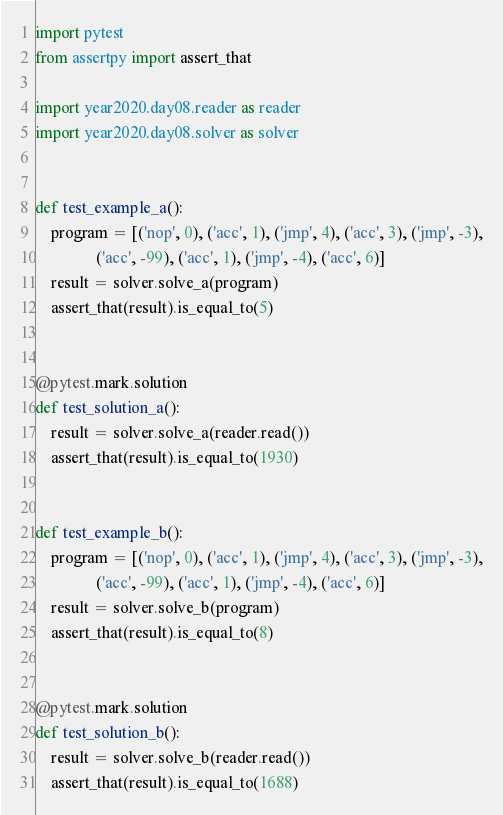Convert code to text. <code><loc_0><loc_0><loc_500><loc_500><_Python_>import pytest
from assertpy import assert_that

import year2020.day08.reader as reader
import year2020.day08.solver as solver


def test_example_a():
    program = [('nop', 0), ('acc', 1), ('jmp', 4), ('acc', 3), ('jmp', -3),
               ('acc', -99), ('acc', 1), ('jmp', -4), ('acc', 6)]
    result = solver.solve_a(program)
    assert_that(result).is_equal_to(5)


@pytest.mark.solution
def test_solution_a():
    result = solver.solve_a(reader.read())
    assert_that(result).is_equal_to(1930)


def test_example_b():
    program = [('nop', 0), ('acc', 1), ('jmp', 4), ('acc', 3), ('jmp', -3),
               ('acc', -99), ('acc', 1), ('jmp', -4), ('acc', 6)]
    result = solver.solve_b(program)
    assert_that(result).is_equal_to(8)


@pytest.mark.solution
def test_solution_b():
    result = solver.solve_b(reader.read())
    assert_that(result).is_equal_to(1688)
</code> 